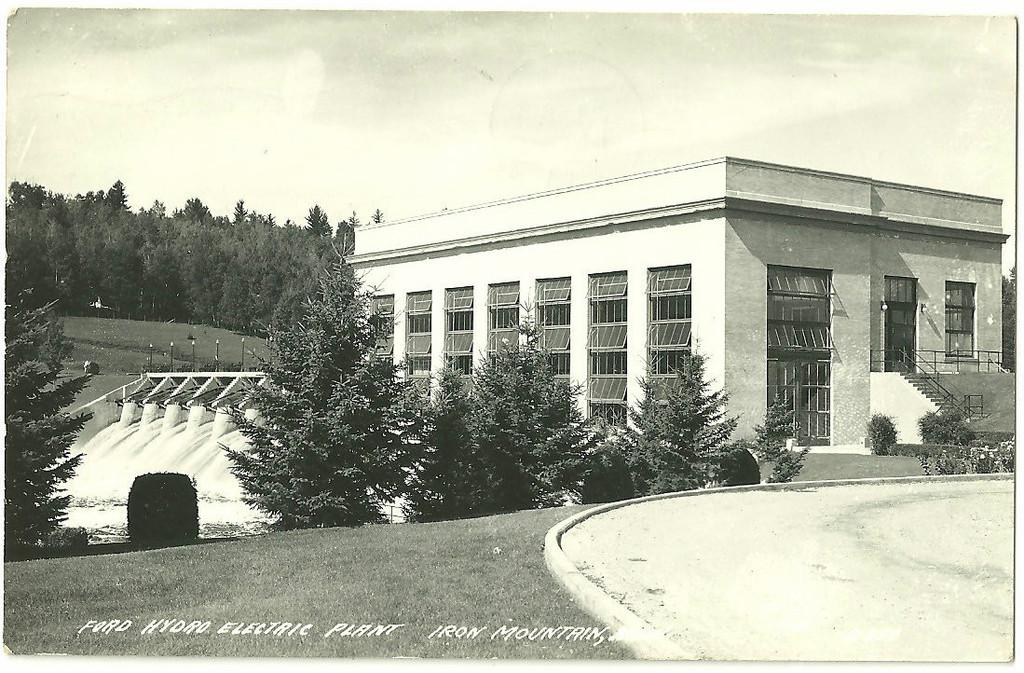What type of structure is present in the image? There is a building in the image. What is one feature of the building that can be seen? There is a door in the image. What is another feature of the building that can be seen? There is a window in the image. Are there any architectural elements visible in the image? Yes, there is a staircase in the image. What type of natural environment is visible in the image? There are trees and grass in the image. What is visible in the sky in the image? The sky is visible in the image. What type of cap can be seen on the mind of the person in the image? There is no person or mind present in the image, and therefore no cap can be seen. 